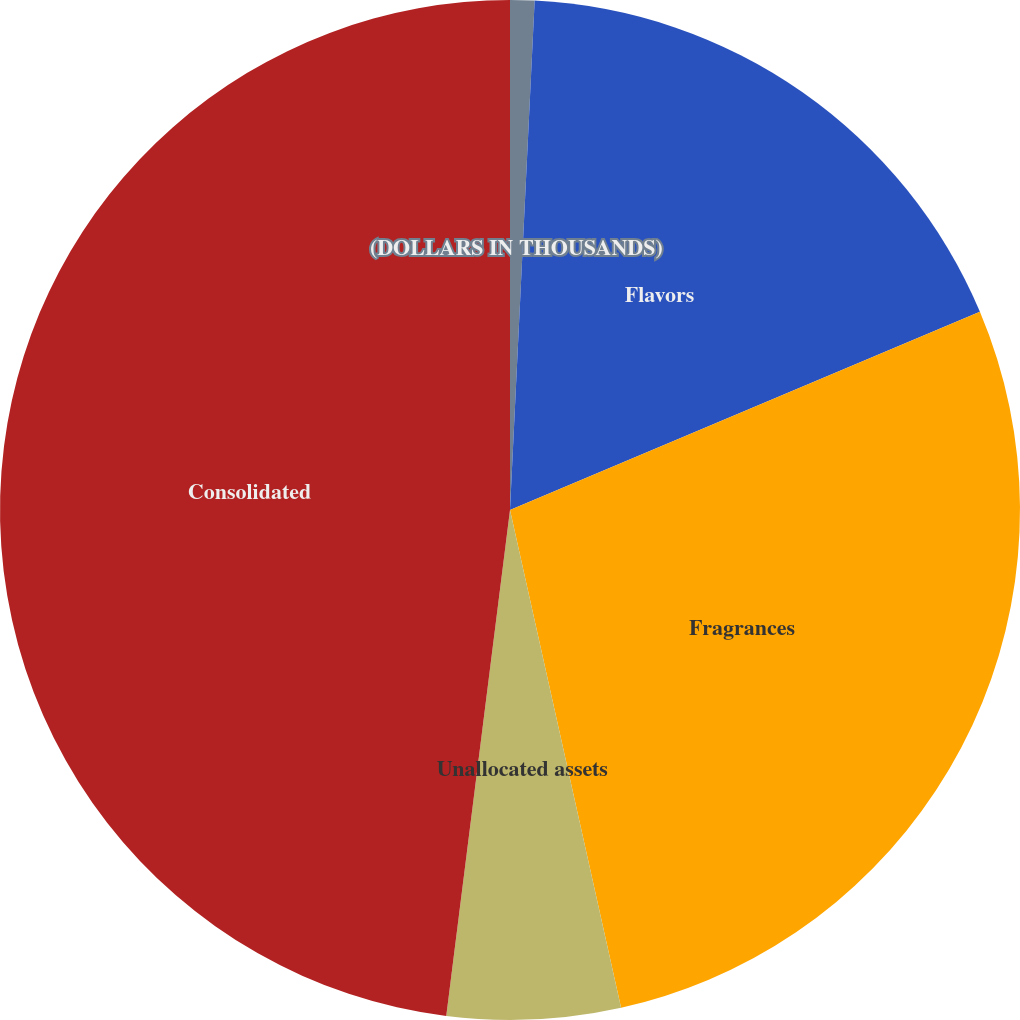Convert chart to OTSL. <chart><loc_0><loc_0><loc_500><loc_500><pie_chart><fcel>(DOLLARS IN THOUSANDS)<fcel>Flavors<fcel>Fragrances<fcel>Unallocated assets<fcel>Consolidated<nl><fcel>0.77%<fcel>17.88%<fcel>27.86%<fcel>5.49%<fcel>48.01%<nl></chart> 